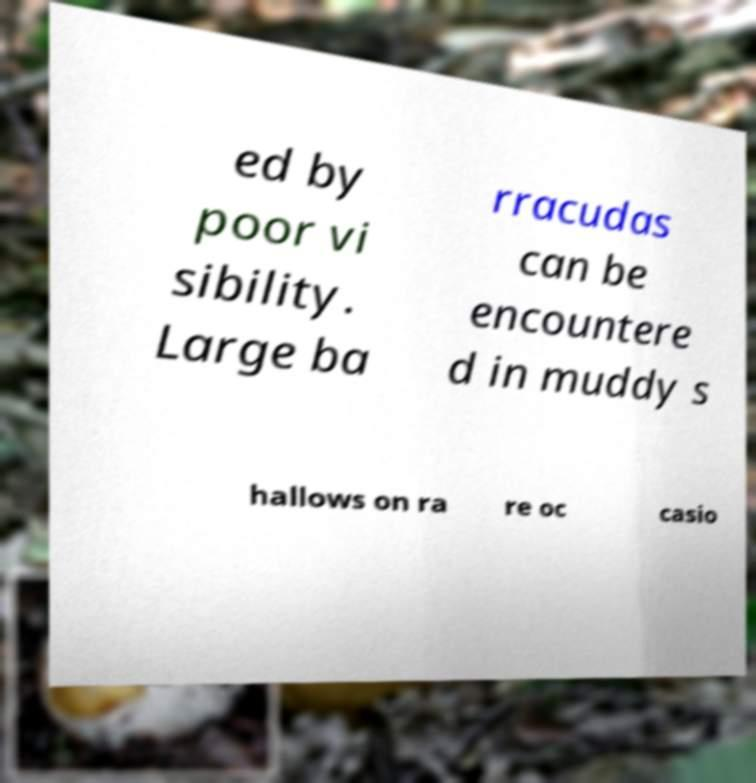Please identify and transcribe the text found in this image. ed by poor vi sibility. Large ba rracudas can be encountere d in muddy s hallows on ra re oc casio 